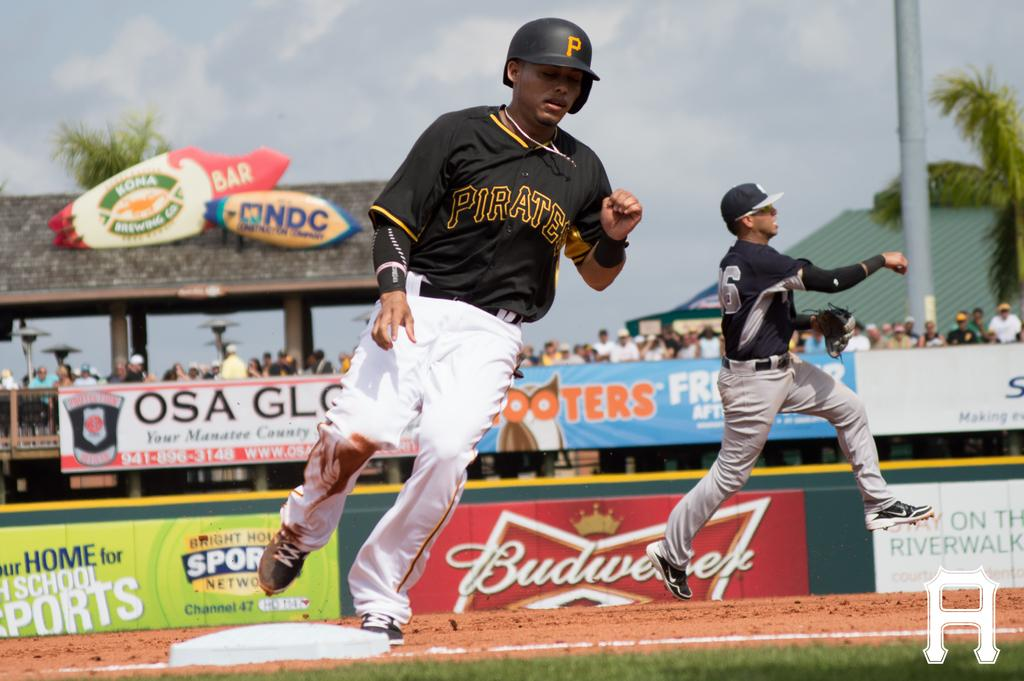Provide a one-sentence caption for the provided image. A player for the Pittsburgh Pirates is running around the bases during a baseball game. 